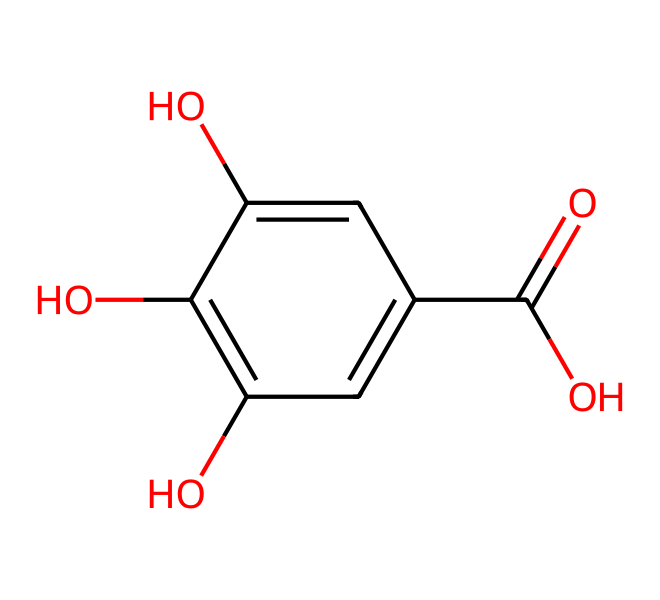what is the total number of carbon atoms in this chemical? By analyzing the SMILES representation, we can count the number of 'c' characters representing carbon atoms. There are a total of six carbon atoms in the structure.
Answer: 6 how many hydroxyl (–OH) groups are present? In the SMILES, we can identify the 'O' and any accompanying 'H' to indicate hydroxyl groups. There are three 'O' atoms that are connected within the ring, representing three hydroxyl groups.
Answer: 3 what type of chemical is represented by this structure? The presence of multiple hydroxyl groups and a carboxylic acid functional group (–COOH) suggests that this molecule is a phenolic compound, typical of natural dyes.
Answer: phenolic how many hydrogen atoms are in the molecule? To find the number of hydrogen atoms, we can apply the general rule for carbon compounds. Each carbon atom typically bonds with enough hydrogen atoms to complete four bonds in total. Counting the hydrogens deduced from the functional groups leads us to conclude that there are six hydrogen atoms in this structure.
Answer: 6 what functional group is indicated by the presence of "O=C(O)" in the structure? The "O=C(O)" indicates a carboxylic acid functional group, which consists of a carbonyl (C=O) and a hydroxyl (–OH) group attached to the same carbon.
Answer: carboxylic acid is this molecule likely to be water-soluble? The presence of three hydroxyl groups and one carboxylic acid group suggests high polarity, which typically increases solubility in water.
Answer: yes 